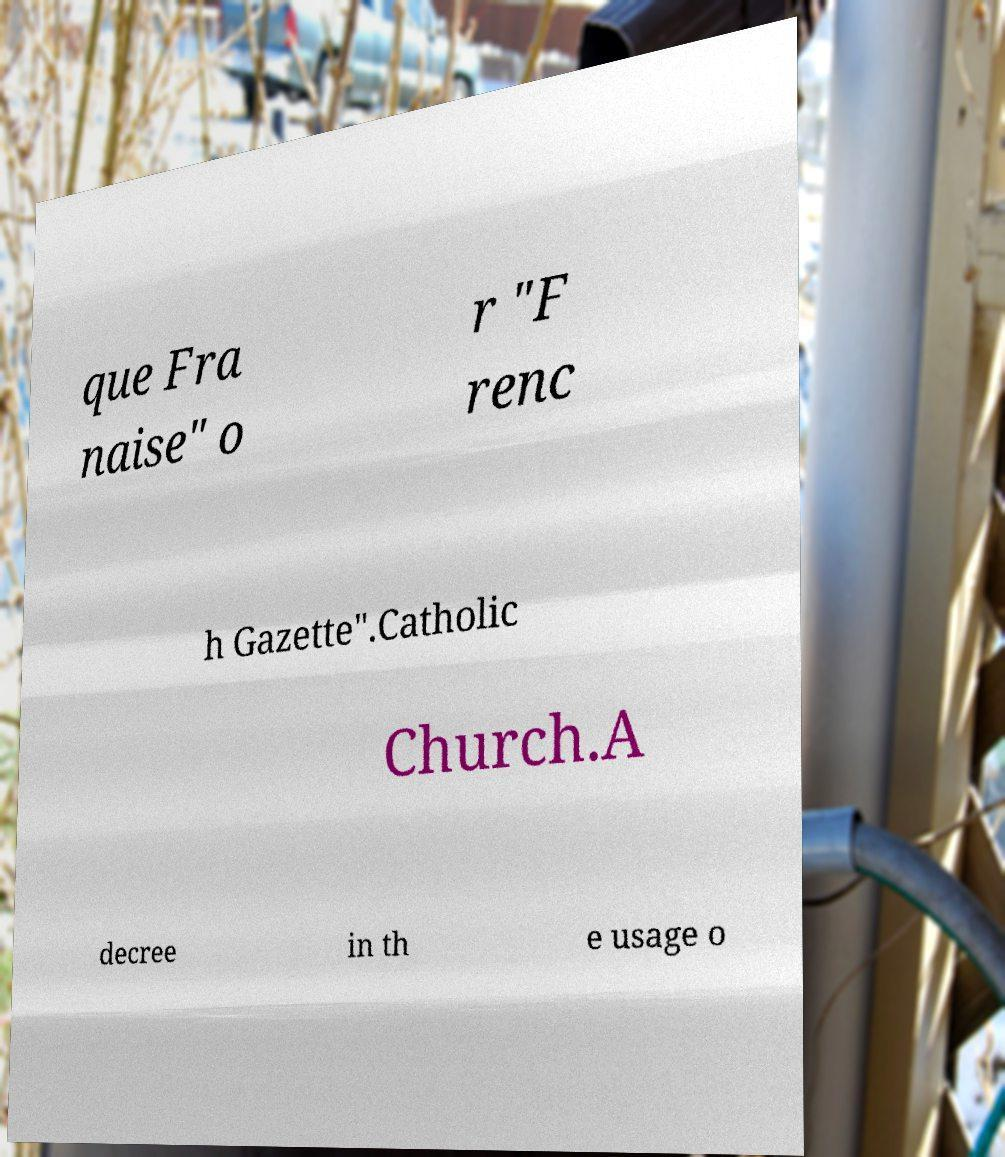Could you assist in decoding the text presented in this image and type it out clearly? que Fra naise" o r "F renc h Gazette".Catholic Church.A decree in th e usage o 